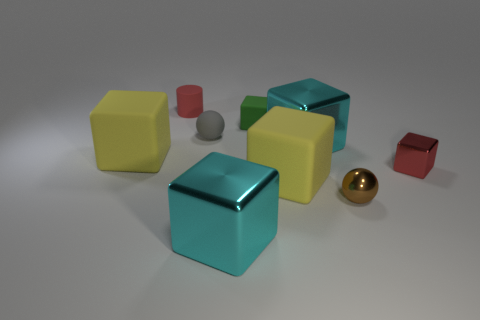What number of objects are either metallic blocks or brown objects?
Make the answer very short. 4. There is a large rubber object behind the red thing on the right side of the small green matte thing; how many blocks are in front of it?
Ensure brevity in your answer.  3. What is the material of the small red thing that is the same shape as the green thing?
Ensure brevity in your answer.  Metal. The tiny object that is both on the right side of the gray sphere and left of the small brown shiny ball is made of what material?
Provide a succinct answer. Rubber. Are there fewer yellow matte blocks in front of the brown metallic object than brown things that are behind the tiny rubber cylinder?
Make the answer very short. No. What number of other things are there of the same size as the metal sphere?
Your answer should be very brief. 4. What shape is the tiny metal thing in front of the tiny block right of the large rubber block that is in front of the red shiny thing?
Give a very brief answer. Sphere. How many green objects are tiny rubber blocks or big cubes?
Provide a short and direct response. 1. How many large yellow rubber things are in front of the red thing that is right of the tiny matte block?
Make the answer very short. 1. Are there any other things of the same color as the small shiny block?
Offer a terse response. Yes. 